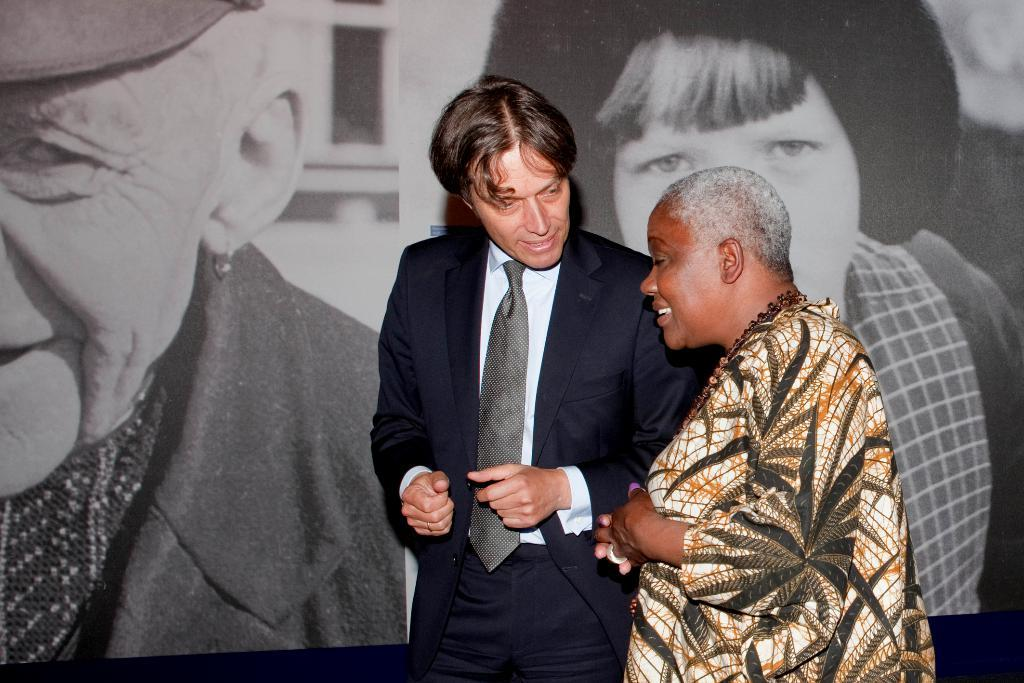What is happening in the image? There are people standing in the image. What can be seen in the background of the image? There is a screen visible in the background of the image. What is displayed on the screen? People are displayed on the screen. How many cherries are on the low branch in the image? There are no cherries or branches present in the image. 